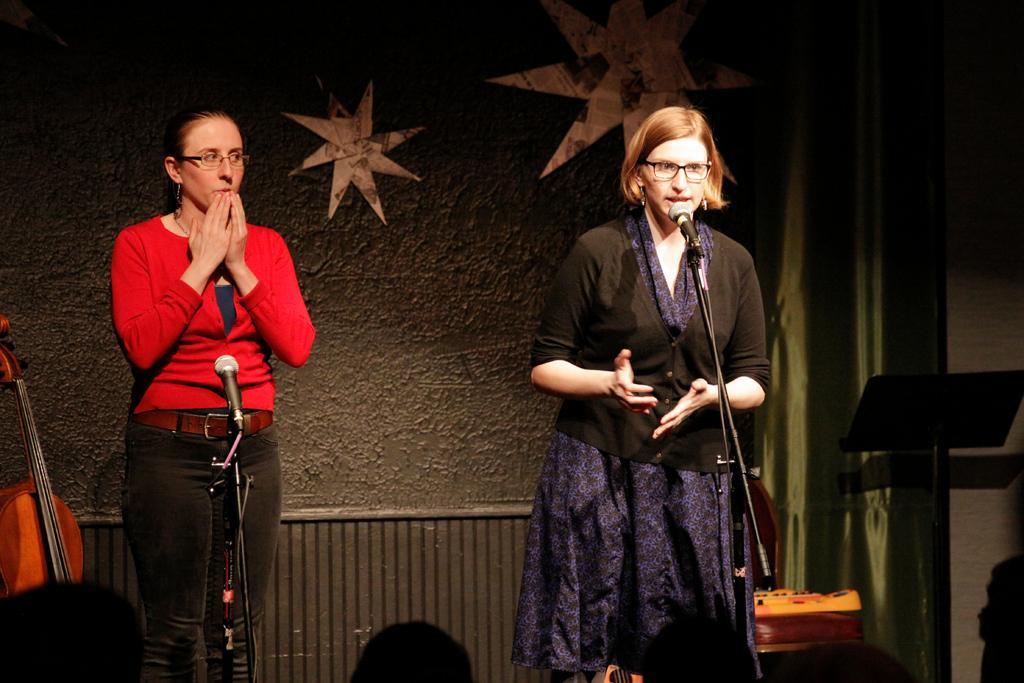Please provide a concise description of this image. In this image we can see two women are standing. One woman is wearing a red color sweater with black jeans and the other woman is wearing dark blue color dress with a black sweater. In front of them, mics are there. We can see the black color stand and wall on the right side of the image. There are people at the bottom of the image. In the background, we can see wall and curtain. There is a guitar on the left side of the image. 